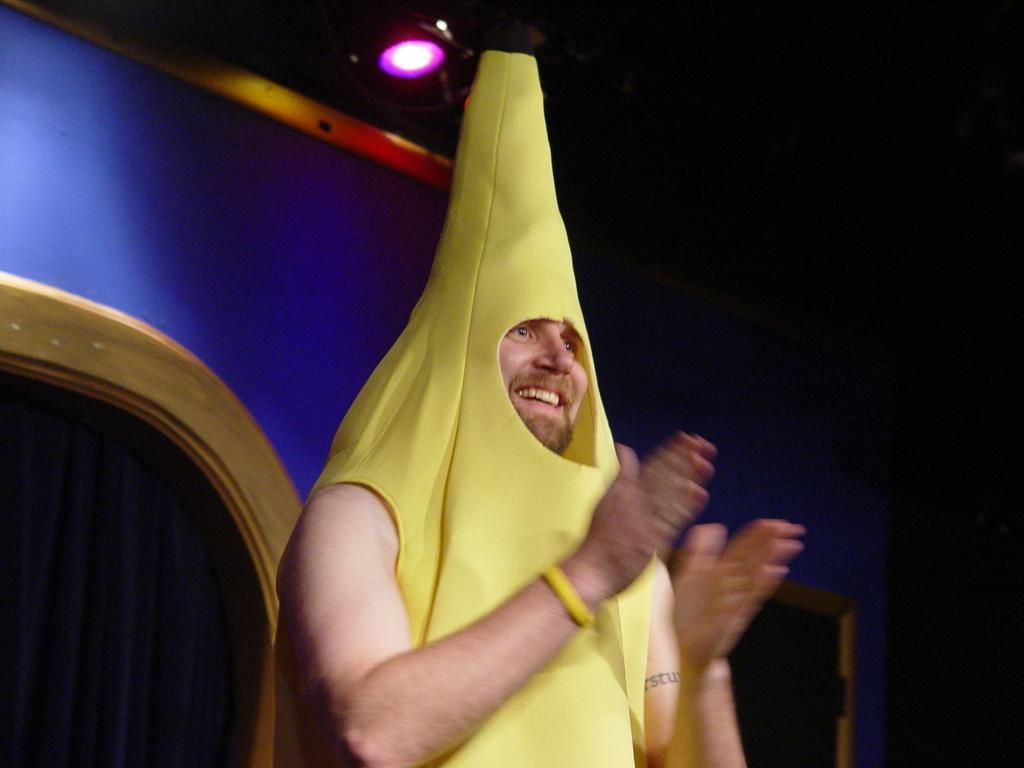Can you describe this image briefly? In this image we can see person is clapping and at the back side there is a wall and at the top there is a light. 